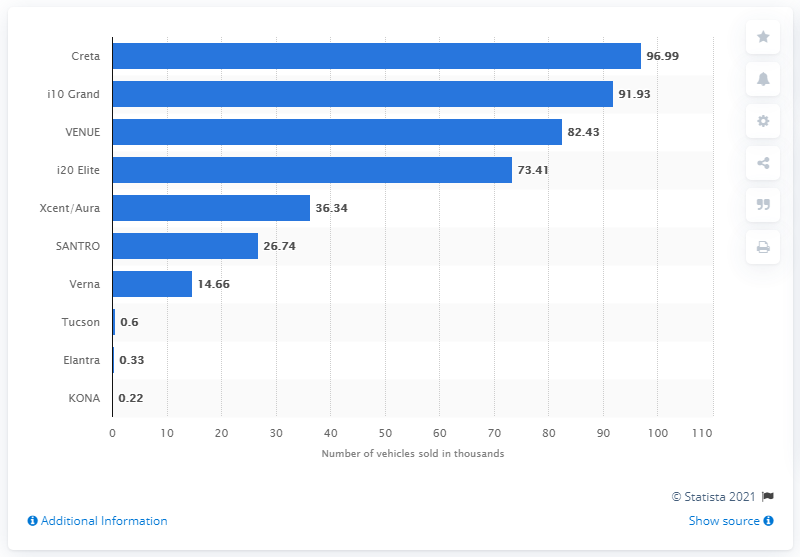Give some essential details in this illustration. The i10 Grand was the second best-selling model produced by Hyundai in India in 2020. 